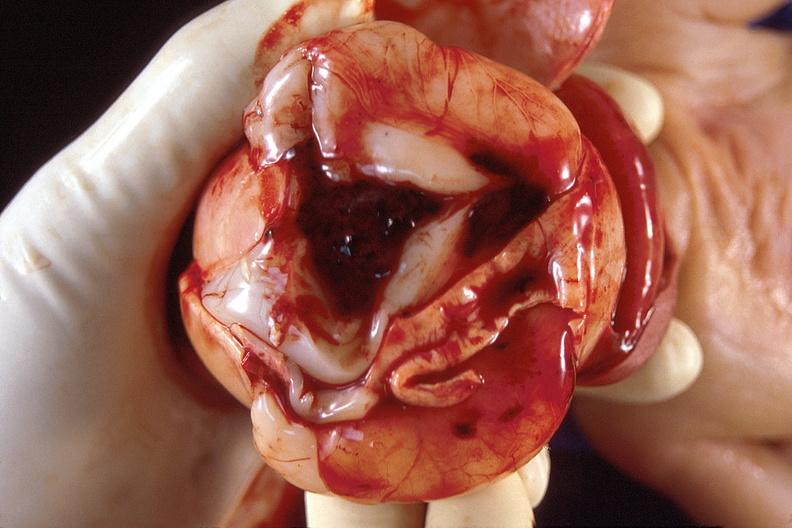what is present?
Answer the question using a single word or phrase. Nervous 